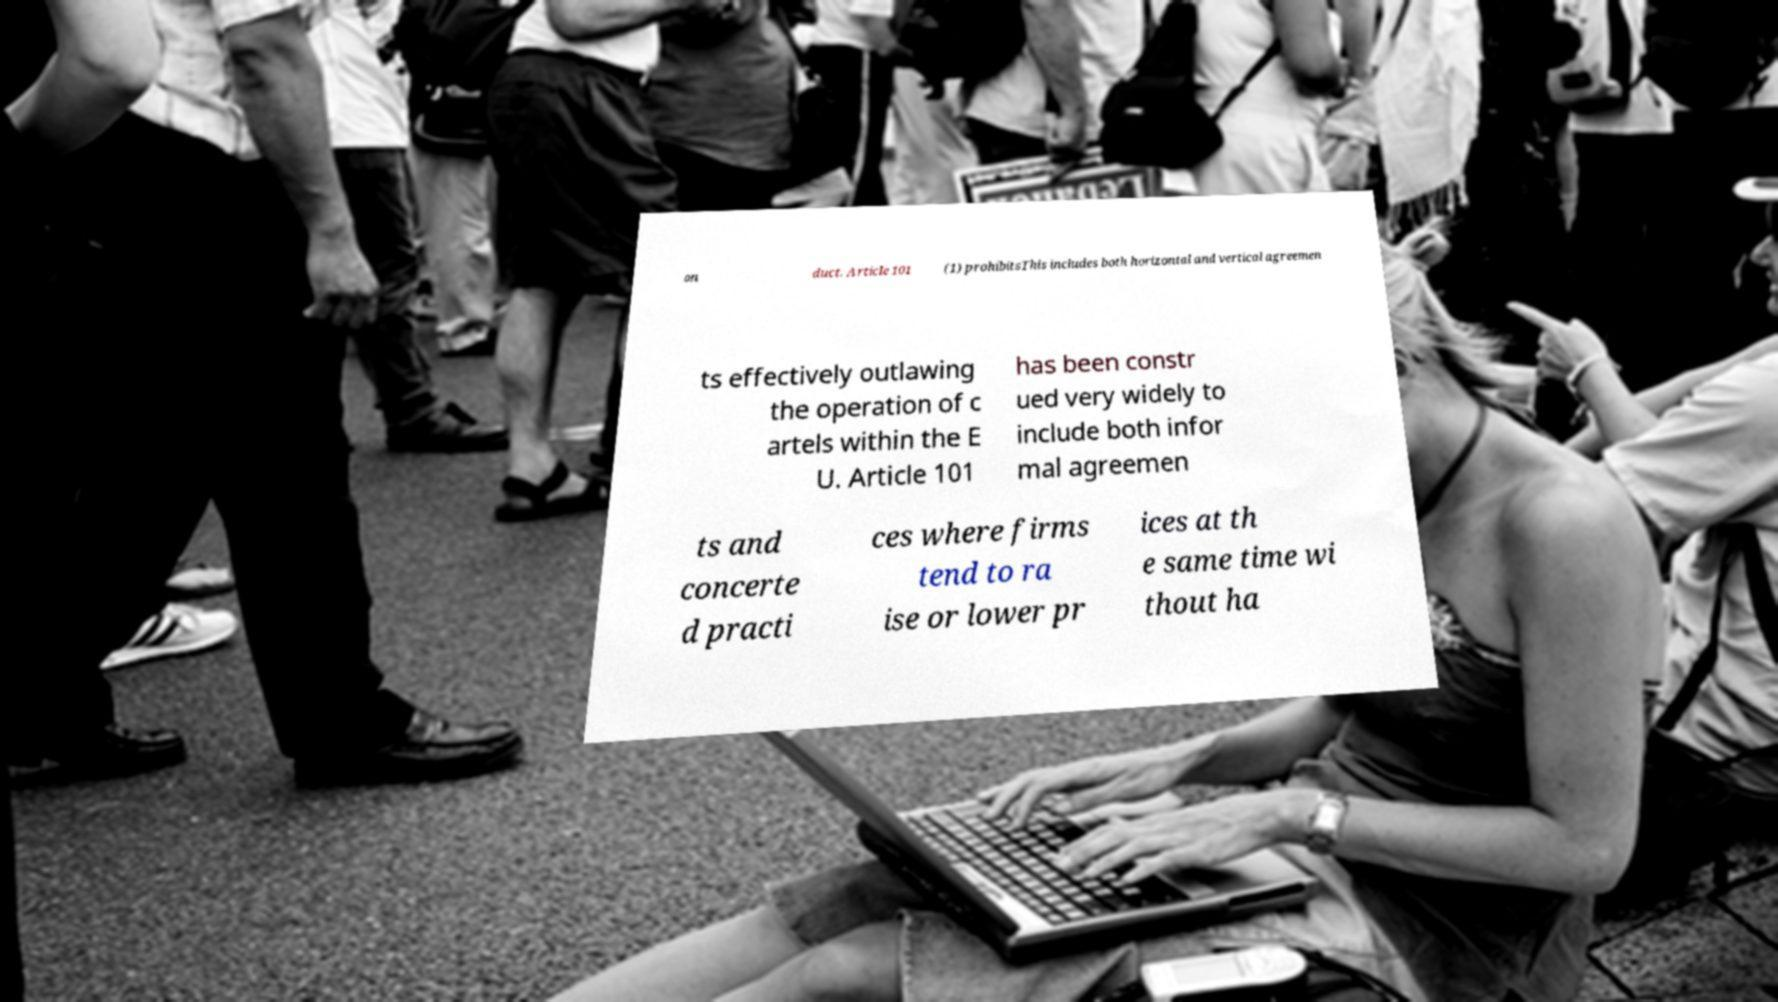I need the written content from this picture converted into text. Can you do that? on duct. Article 101 (1) prohibitsThis includes both horizontal and vertical agreemen ts effectively outlawing the operation of c artels within the E U. Article 101 has been constr ued very widely to include both infor mal agreemen ts and concerte d practi ces where firms tend to ra ise or lower pr ices at th e same time wi thout ha 